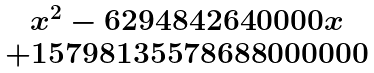<formula> <loc_0><loc_0><loc_500><loc_500>\begin{matrix} x ^ { 2 } - 6 2 9 4 8 4 2 6 4 0 0 0 0 x \\ + 1 5 7 9 8 1 3 5 5 7 8 6 8 8 0 0 0 0 0 0 \end{matrix}</formula> 